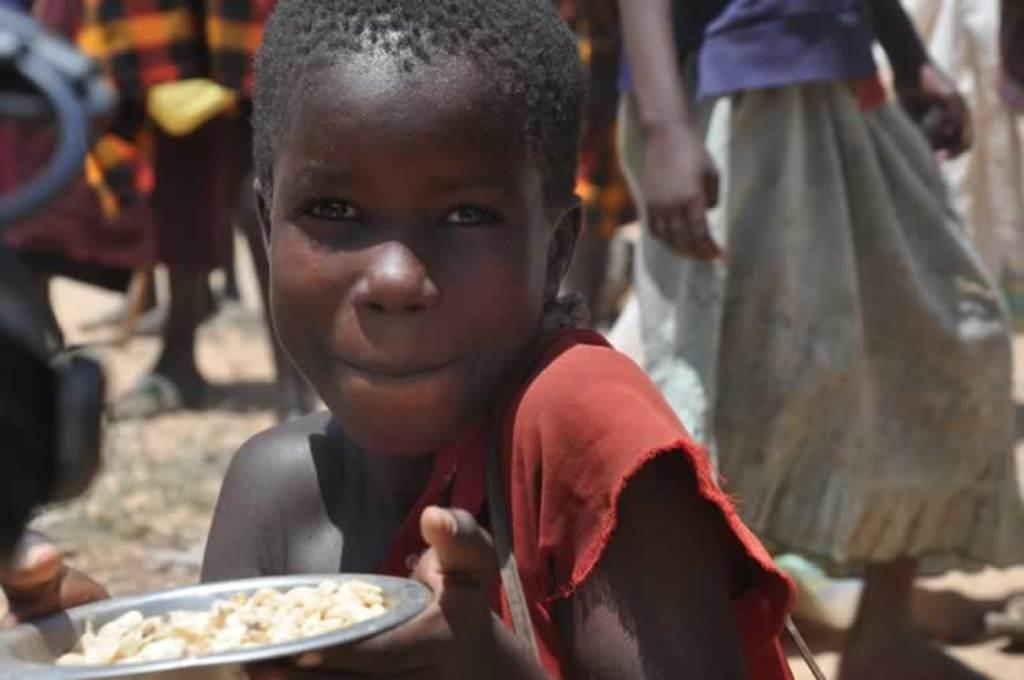Who is present in the image? There is a person in the image. What is the person wearing? The person is wearing a red dress. What is the person holding in the image? The person is holding a plate with a food item. Can you describe the surroundings of the person? There are other persons visible in the background of the image. How many icicles are hanging from the person's legs in the image? There are no icicles present in the image, and the person's legs are not visible. 